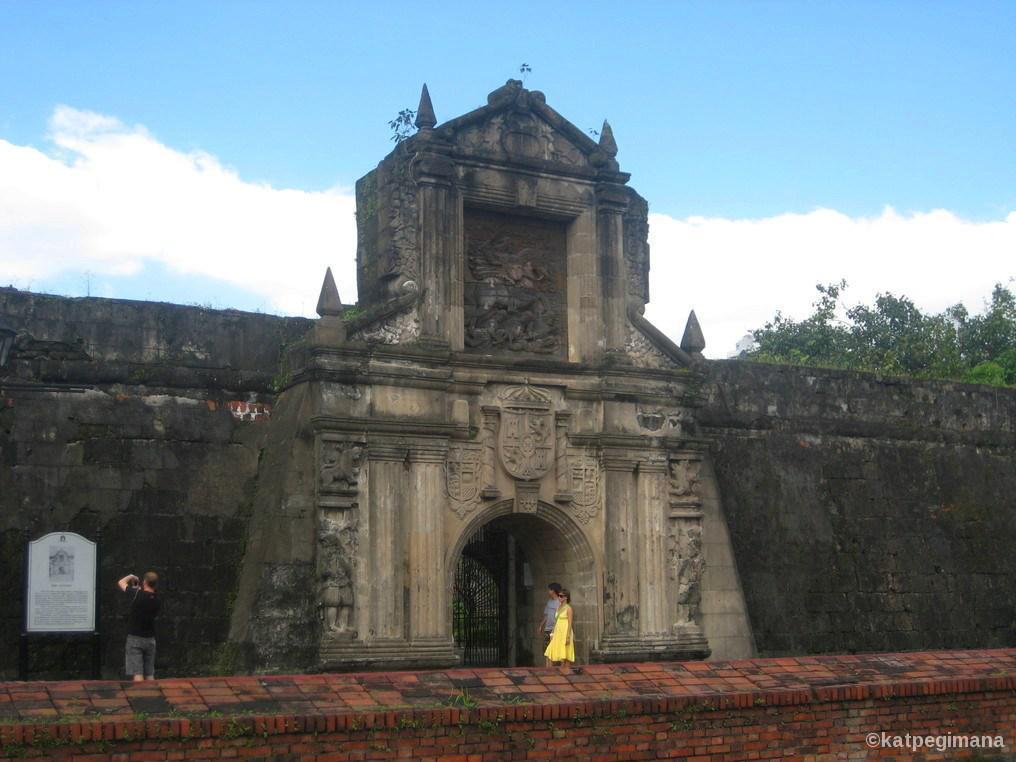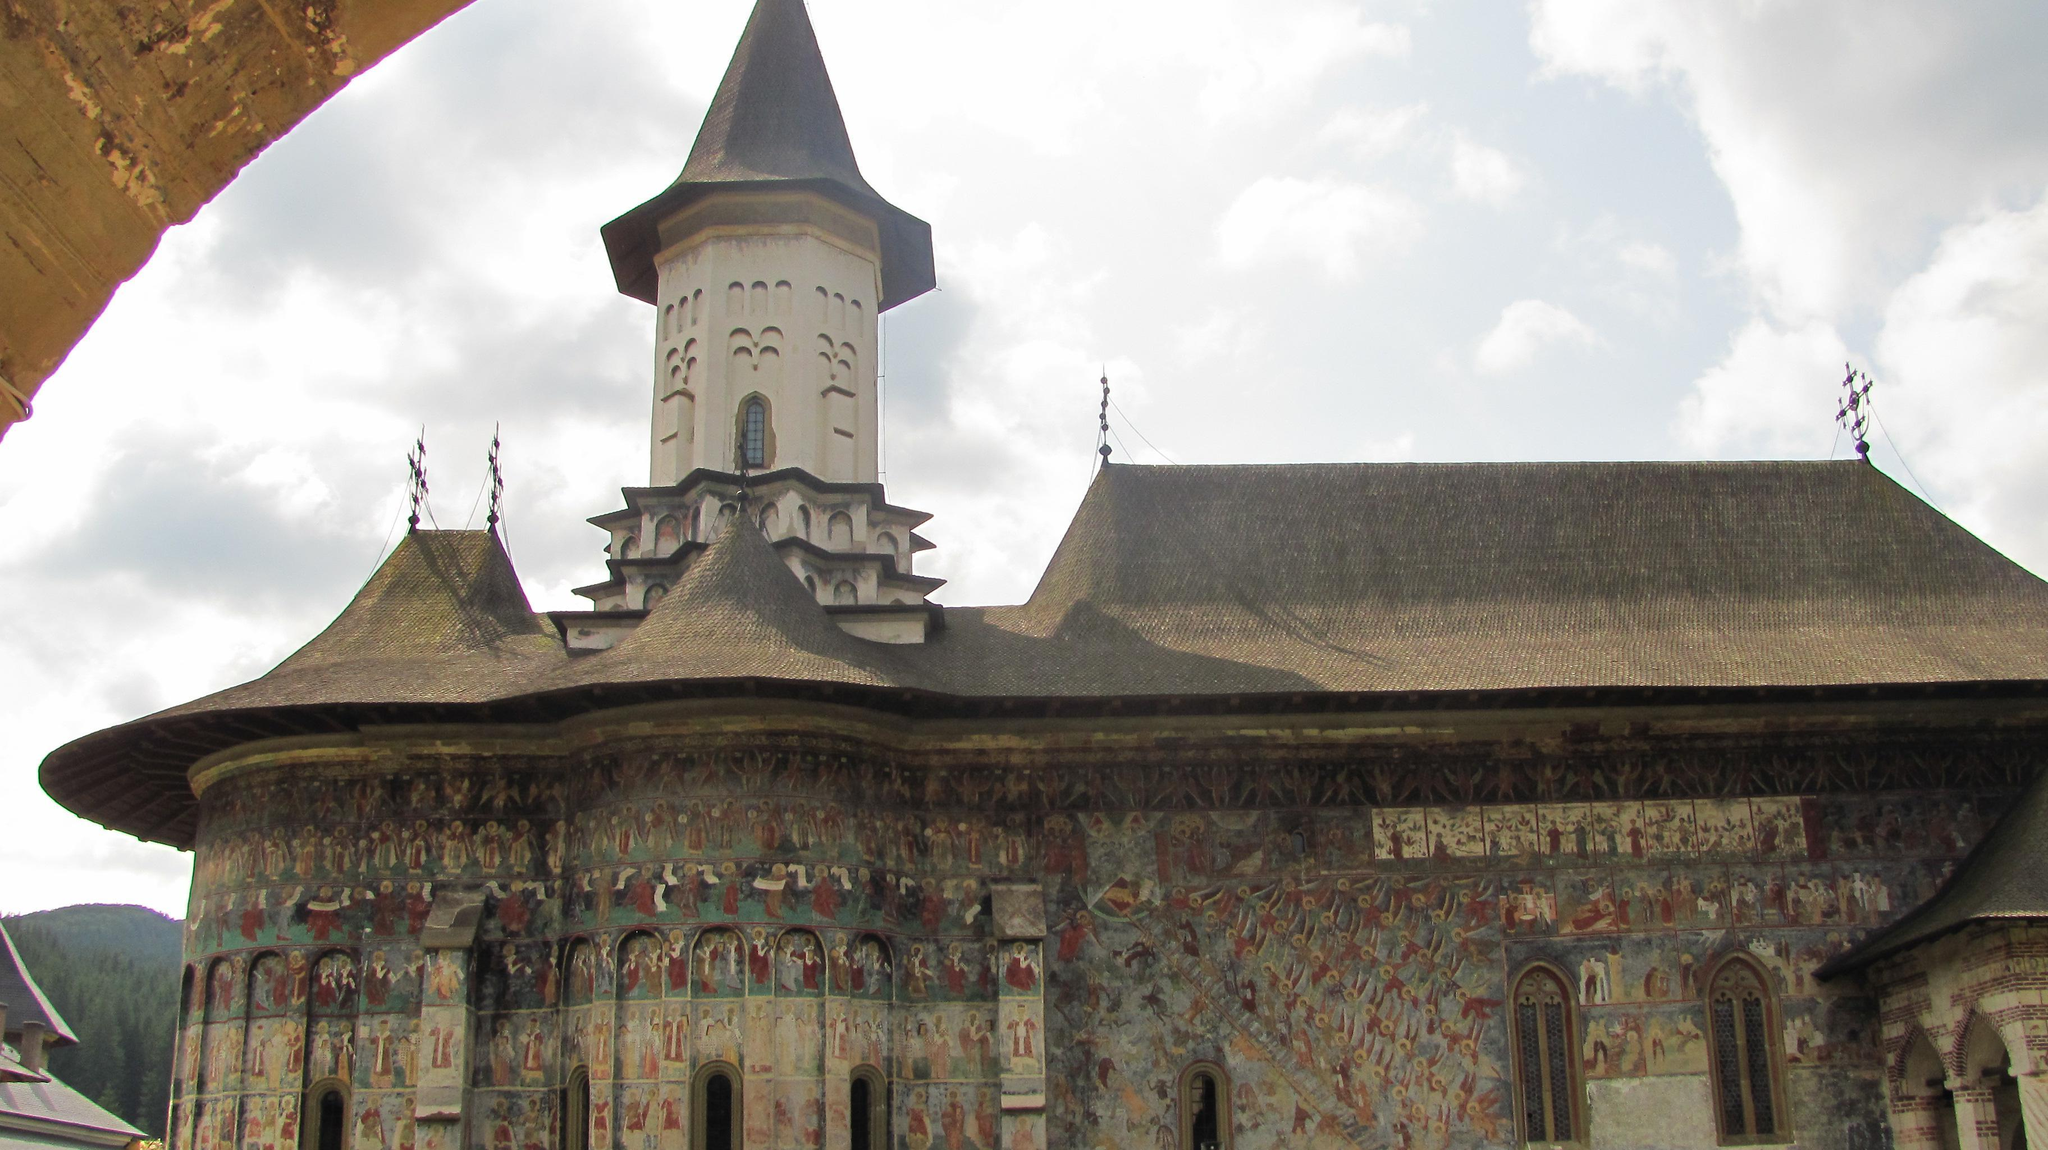The first image is the image on the left, the second image is the image on the right. Given the left and right images, does the statement "There are two crosses on the building in at least one of the images." hold true? Answer yes or no. No. The first image is the image on the left, the second image is the image on the right. Considering the images on both sides, is "An image shows a mottled gray building with a cone-shaped roof that has something growing on it." valid? Answer yes or no. No. 